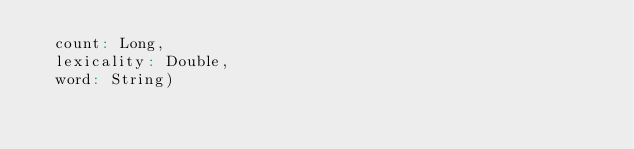<code> <loc_0><loc_0><loc_500><loc_500><_Scala_>  count: Long,
  lexicality: Double,
  word: String)

</code> 